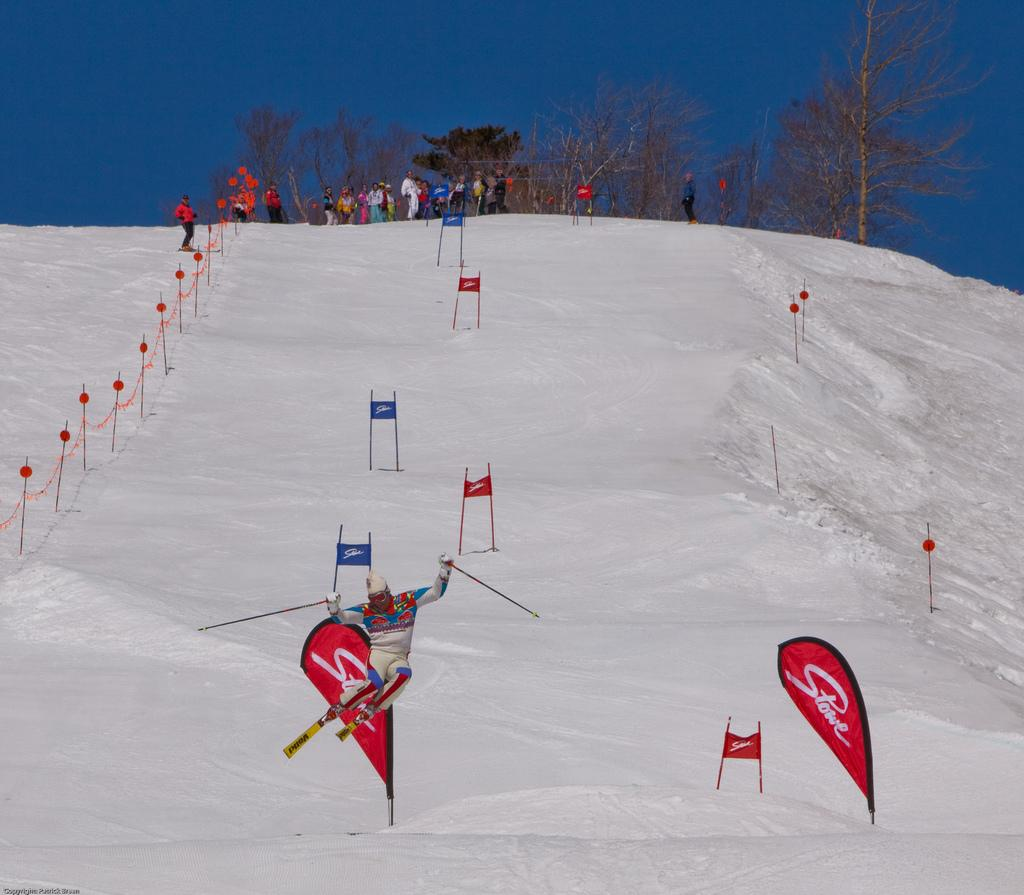<image>
Create a compact narrative representing the image presented. A man wearing a white uniform skiing on a red board from Stowe 